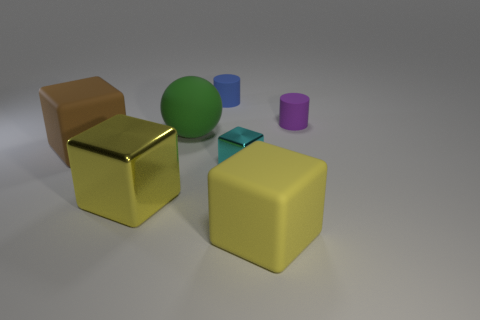Subtract all big cubes. How many cubes are left? 1 Subtract all yellow blocks. How many blocks are left? 2 Add 3 big brown rubber objects. How many objects exist? 10 Subtract 2 cubes. How many cubes are left? 2 Subtract all cylinders. How many objects are left? 5 Subtract all red cubes. How many blue cylinders are left? 1 Add 6 small cyan blocks. How many small cyan blocks exist? 7 Subtract 1 blue cylinders. How many objects are left? 6 Subtract all gray cubes. Subtract all gray cylinders. How many cubes are left? 4 Subtract all big brown rubber blocks. Subtract all rubber spheres. How many objects are left? 5 